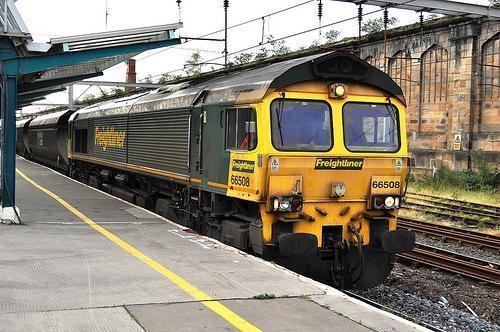How many trains are in the photo?
Give a very brief answer. 1. 